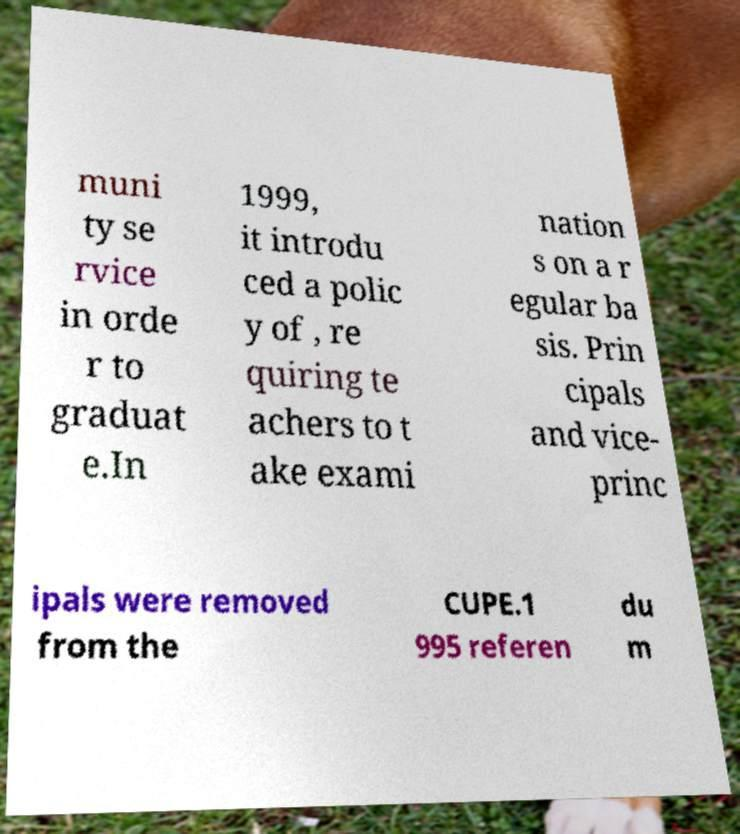Please identify and transcribe the text found in this image. muni ty se rvice in orde r to graduat e.In 1999, it introdu ced a polic y of , re quiring te achers to t ake exami nation s on a r egular ba sis. Prin cipals and vice- princ ipals were removed from the CUPE.1 995 referen du m 